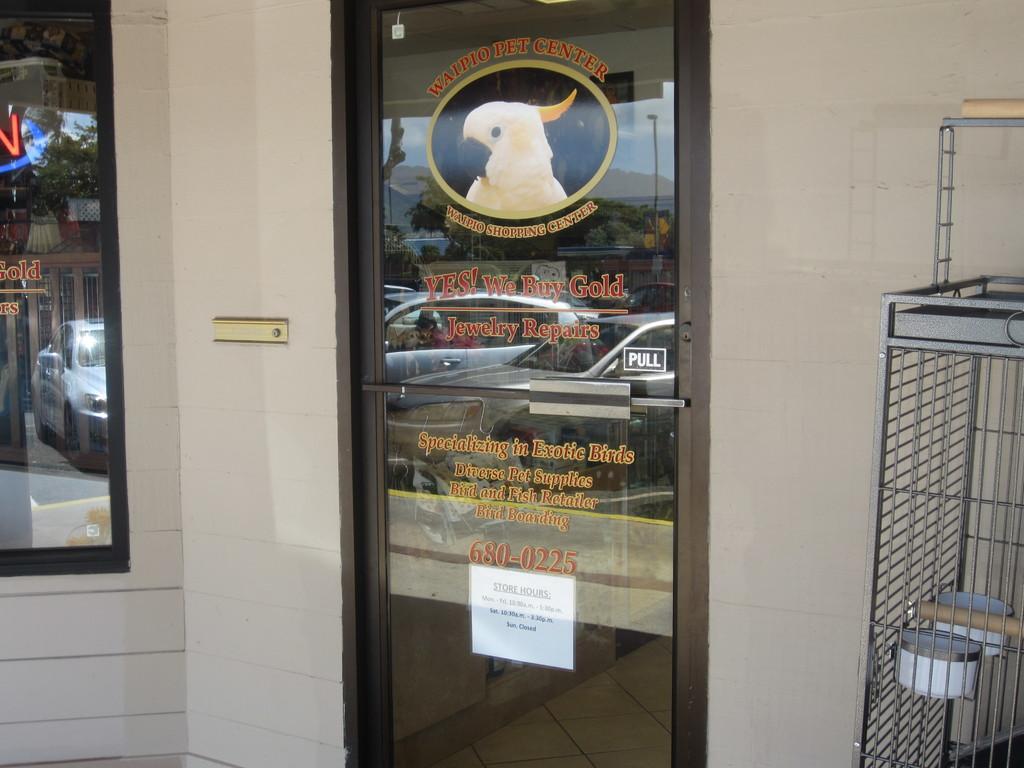In one or two sentences, can you explain what this image depicts? Here I can see a wall in white color. There is a door and window on which I can see some text and a white color paper is attached to the door. On the right side I can see a metal stand. 